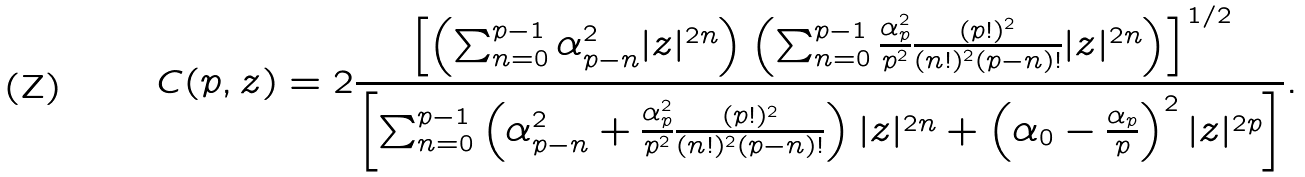Convert formula to latex. <formula><loc_0><loc_0><loc_500><loc_500>C ( p , z ) = 2 \frac { \left [ \left ( \sum _ { n = 0 } ^ { p - 1 } \alpha _ { p - n } ^ { 2 } | z | ^ { 2 n } \right ) \left ( \sum _ { n = 0 } ^ { p - 1 } \frac { \alpha _ { p } ^ { 2 } } { p ^ { 2 } } \frac { ( p ! ) ^ { 2 } } { ( n ! ) ^ { 2 } ( p - n ) ! } | z | ^ { 2 n } \right ) \right ] ^ { 1 / 2 } } { \left [ \sum _ { n = 0 } ^ { p - 1 } \left ( \alpha _ { p - n } ^ { 2 } + \frac { \alpha _ { p } ^ { 2 } } { p ^ { 2 } } \frac { ( p ! ) ^ { 2 } } { ( n ! ) ^ { 2 } ( p - n ) ! } \right ) | z | ^ { 2 n } + \left ( \alpha _ { 0 } - \frac { \alpha _ { p } } { p } \right ) ^ { 2 } | z | ^ { 2 p } \right ] } .</formula> 